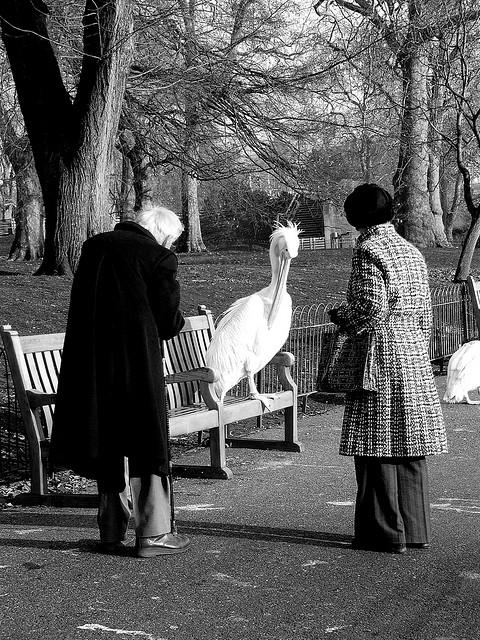Are they taking a picture?
Concise answer only. No. How many people are there?
Write a very short answer. 2. What is on the bench?
Keep it brief. Bird. 